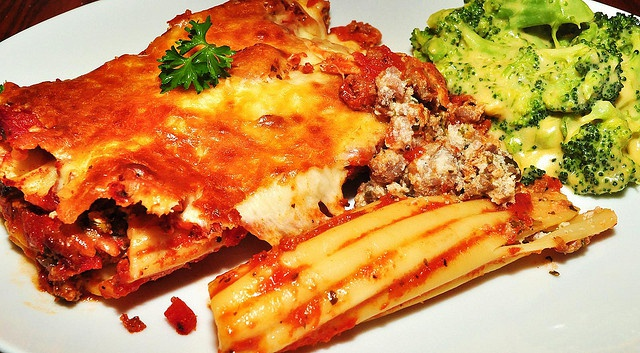Describe the objects in this image and their specific colors. I can see dining table in ivory, red, orange, and gold tones, sandwich in maroon, red, brown, and orange tones, and broccoli in maroon, khaki, olive, gold, and darkgreen tones in this image. 